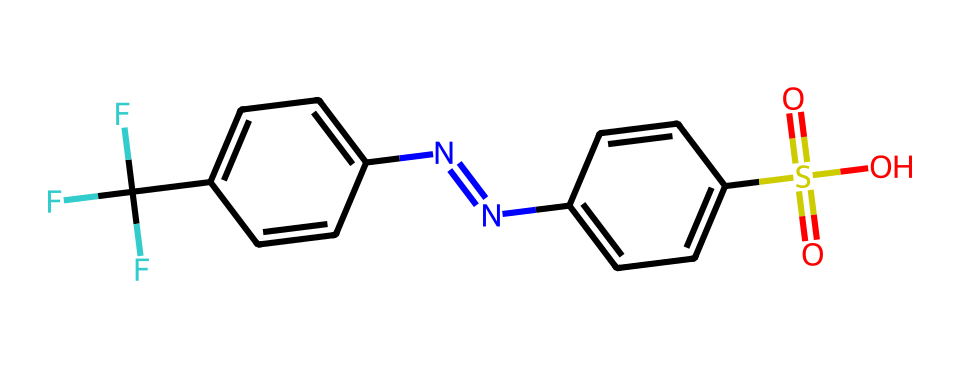What is the total number of fluorine atoms in the chemical structure? The SMILES representation shows "FC(F)(F)", indicating there are three fluorine atoms attached to the carbon (C). Counting them gives a total of 3.
Answer: 3 How many nitrogen atoms are present in the molecule? In the SMILES, "N=N" indicates a diazo group, contributing two nitrogen atoms. Thus, the total in the molecule is 2.
Answer: 2 What functional group is represented by "S(=O)(=O)O"? The presence of "S(=O)(=O)O" signifies a sulfonic acid functional group (sulfonate), characterized by a sulfur atom bonded to three oxygen atoms, two with double bonds and one with a single bond.
Answer: sulfonic acid Which halogen is present in this molecule? The molecule has fluorine atoms noted as "F", which is the only halogen indicated in the SMILES string. Therefore, the present halogen is fluorine.
Answer: fluorine What is the core structure of this molecule based on the benzene rings? The structure features two benzene rings connected by a diazo bridge (N=N), characteristic of azo compounds. The presence of these rings indicates that the core structure is aromatic.
Answer: aromatic How many total carbon atoms are there in the entire molecule? By analyzing "c1ccc()" and the attached groups, the core benzene rings contribute six carbon atoms. The additional carbon from "FC(F)(F)" adds one more. Therefore, there are a total of 7 carbon atoms.
Answer: 7 